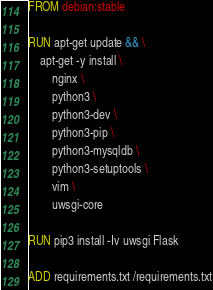Convert code to text. <code><loc_0><loc_0><loc_500><loc_500><_Dockerfile_>FROM debian:stable

RUN apt-get update && \
    apt-get -y install \
        nginx \
        python3 \
        python3-dev \
        python3-pip \
        python3-mysqldb \
        python3-setuptools \
        vim \
        uwsgi-core

RUN pip3 install -Iv uwsgi Flask

ADD requirements.txt /requirements.txt</code> 